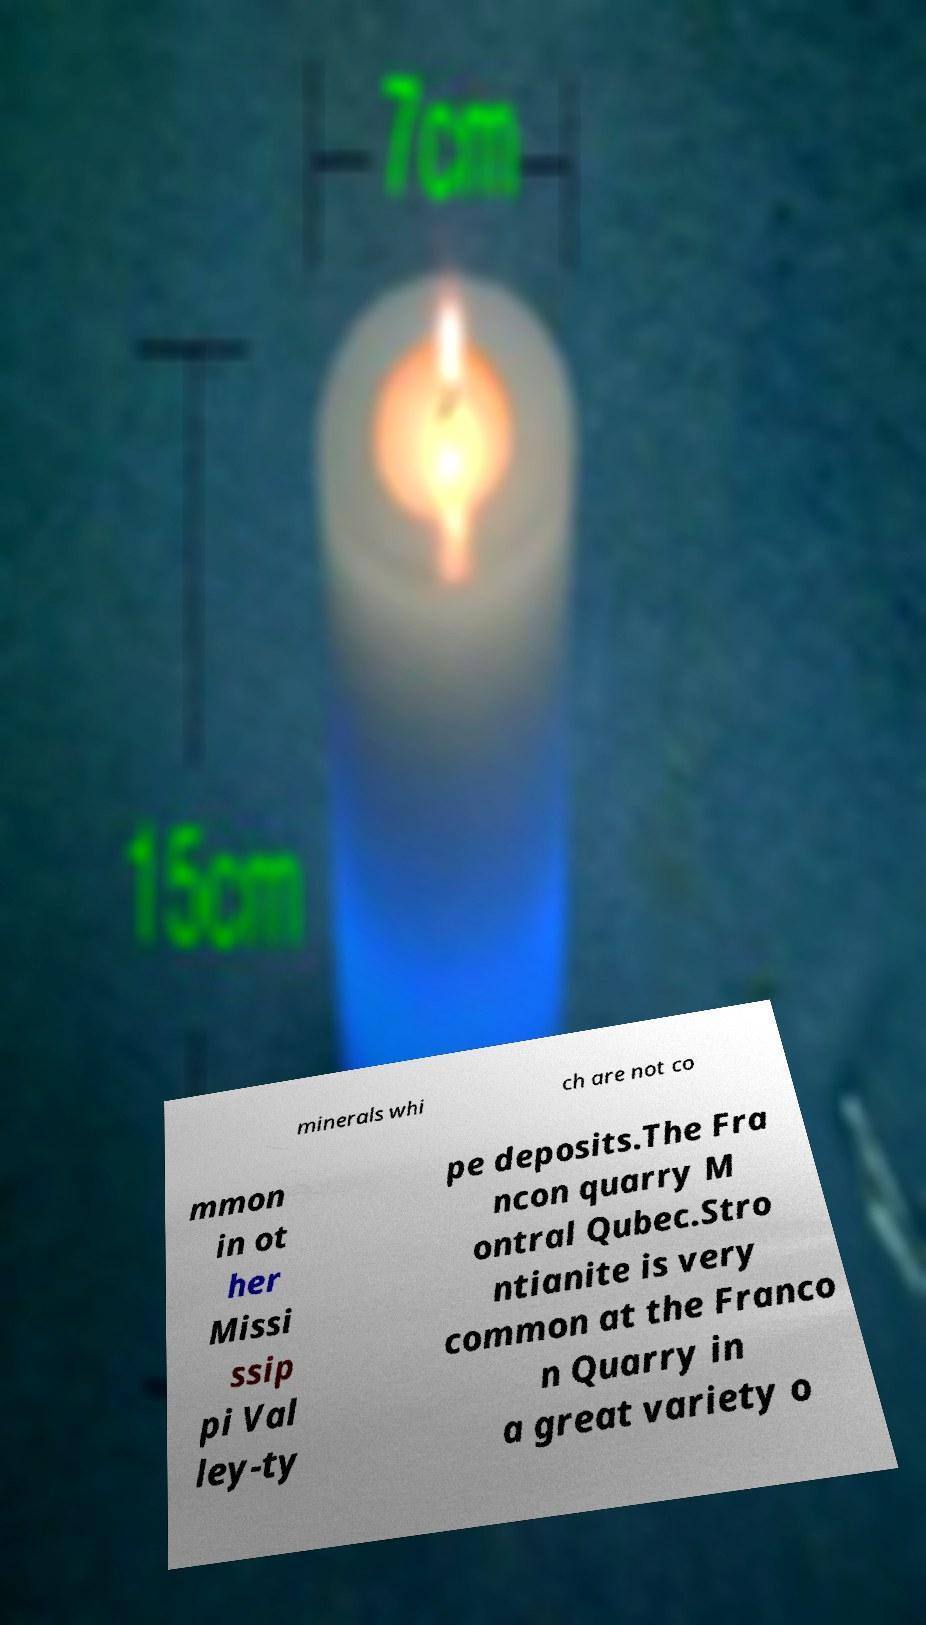Could you assist in decoding the text presented in this image and type it out clearly? minerals whi ch are not co mmon in ot her Missi ssip pi Val ley-ty pe deposits.The Fra ncon quarry M ontral Qubec.Stro ntianite is very common at the Franco n Quarry in a great variety o 